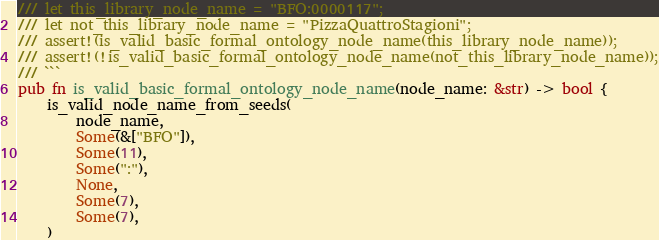<code> <loc_0><loc_0><loc_500><loc_500><_Rust_>/// let this_library_node_name = "BFO:0000117";
/// let not_this_library_node_name = "PizzaQuattroStagioni";
/// assert!(is_valid_basic_formal_ontology_node_name(this_library_node_name));
/// assert!(!is_valid_basic_formal_ontology_node_name(not_this_library_node_name));
/// ```
pub fn is_valid_basic_formal_ontology_node_name(node_name: &str) -> bool {
    is_valid_node_name_from_seeds(
        node_name,
        Some(&["BFO"]),
        Some(11),
        Some(":"),
        None,
        Some(7),
        Some(7),
    )</code> 